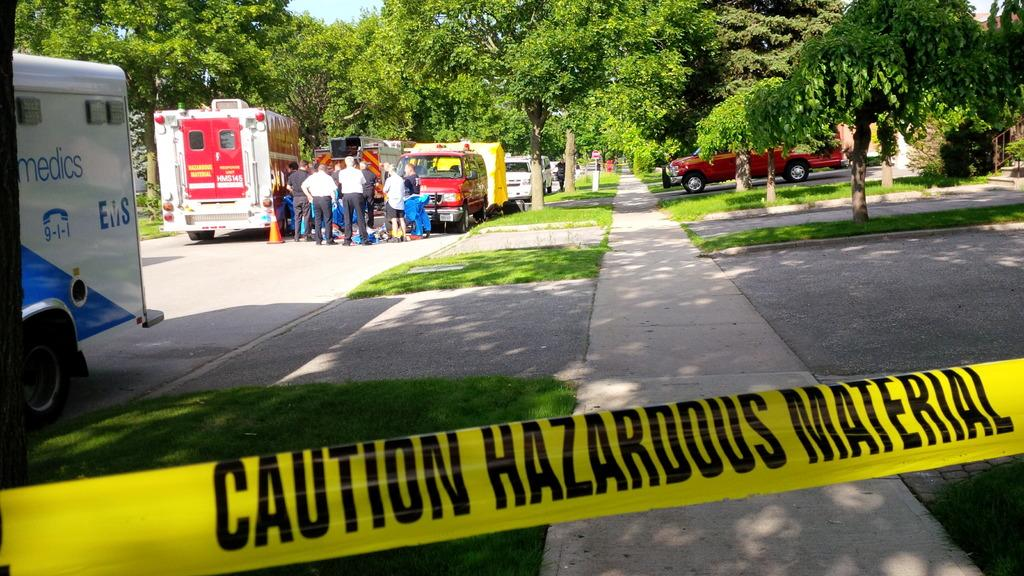What can be seen in the image? There are different types of vehicles in the image. Are there any people in the image? Yes, there are persons standing near the vehicles. What can be seen in the distance in the image? There are trees visible in the background of the image. What type of food is being served at the nation's celebration in the image? There is no nation's celebration or food present in the image; it features vehicles and people near them. 